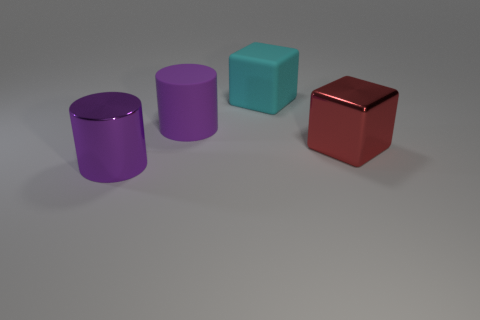How many rubber objects are the same size as the red cube?
Give a very brief answer. 2. How many things are both in front of the big red metal object and behind the rubber cylinder?
Your response must be concise. 0. Does the metal object in front of the red object have the same size as the large red object?
Make the answer very short. Yes. Are there any objects that have the same color as the large matte cylinder?
Your answer should be compact. Yes. Is the number of cyan cubes that are behind the big red metallic thing greater than the number of big cylinders that are behind the rubber cylinder?
Provide a short and direct response. Yes. What number of other things are there of the same material as the red cube
Your answer should be very brief. 1. Are the block that is on the right side of the large cyan object and the big cyan block made of the same material?
Provide a succinct answer. No. What is the shape of the large red thing?
Make the answer very short. Cube. Are there more cyan things in front of the big purple metallic cylinder than objects?
Make the answer very short. No. There is another object that is the same shape as the purple matte thing; what color is it?
Provide a short and direct response. Purple. 